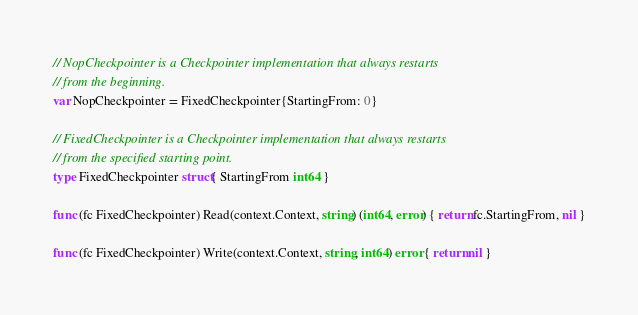Convert code to text. <code><loc_0><loc_0><loc_500><loc_500><_Go_>// NopCheckpointer is a Checkpointer implementation that always restarts
// from the beginning.
var NopCheckpointer = FixedCheckpointer{StartingFrom: 0}

// FixedCheckpointer is a Checkpointer implementation that always restarts
// from the specified starting point.
type FixedCheckpointer struct{ StartingFrom int64 }

func (fc FixedCheckpointer) Read(context.Context, string) (int64, error) { return fc.StartingFrom, nil }

func (fc FixedCheckpointer) Write(context.Context, string, int64) error { return nil }
</code> 